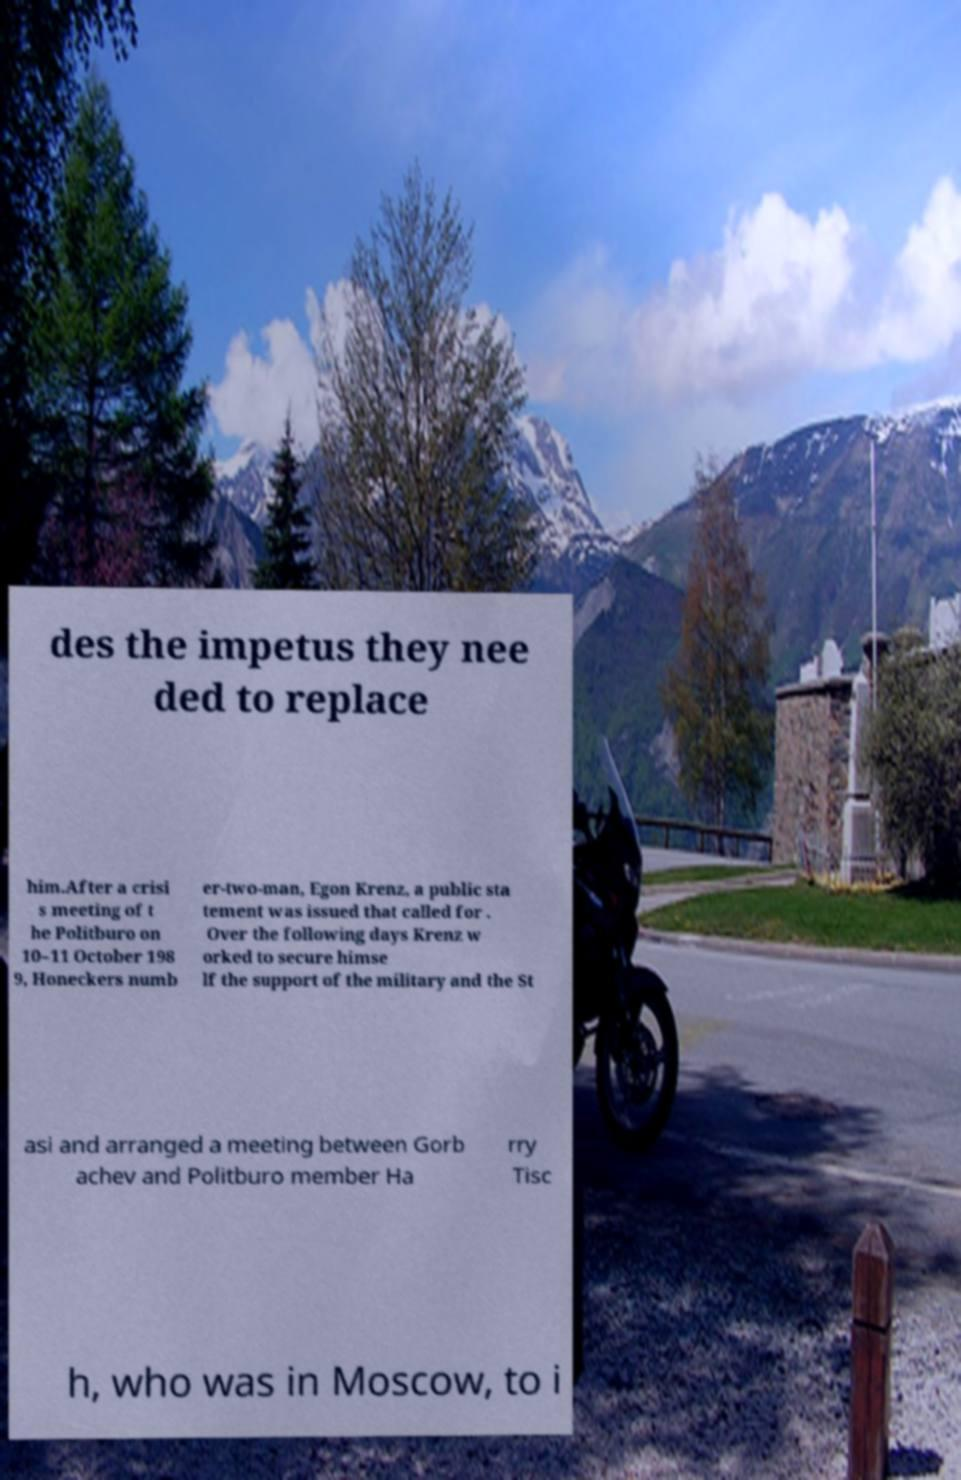There's text embedded in this image that I need extracted. Can you transcribe it verbatim? des the impetus they nee ded to replace him.After a crisi s meeting of t he Politburo on 10–11 October 198 9, Honeckers numb er-two-man, Egon Krenz, a public sta tement was issued that called for . Over the following days Krenz w orked to secure himse lf the support of the military and the St asi and arranged a meeting between Gorb achev and Politburo member Ha rry Tisc h, who was in Moscow, to i 